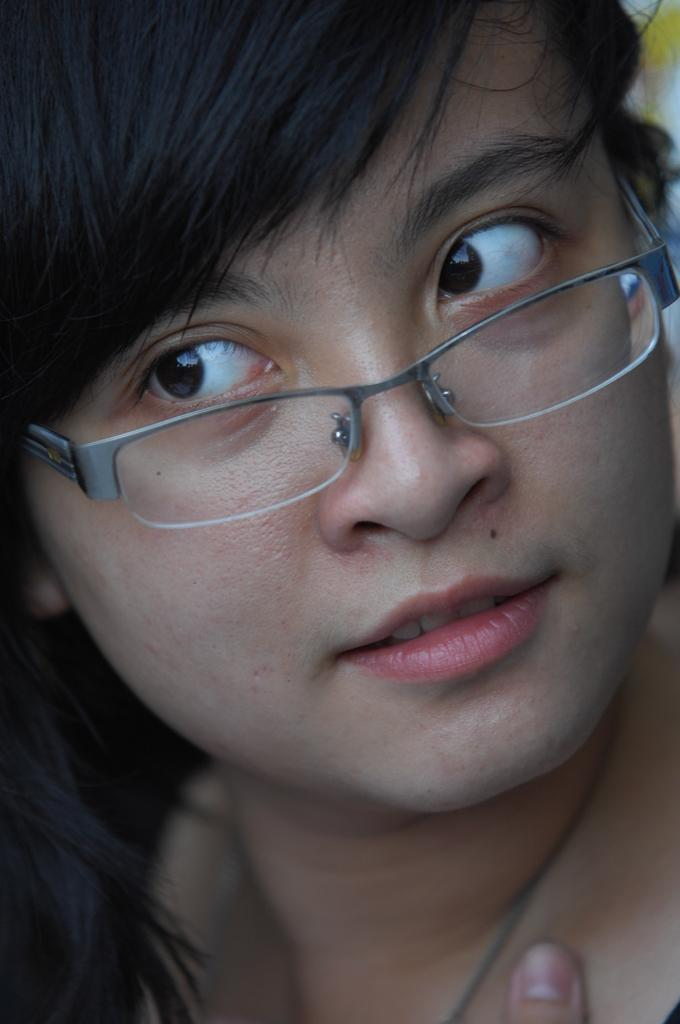What is present in the image? There is a person in the image. Can you describe the person's appearance? The person is wearing spectacles. What type of animal is shown biting the person's spectacles in the image? There is no animal present in the image, and the person's spectacles are not being bitten. 